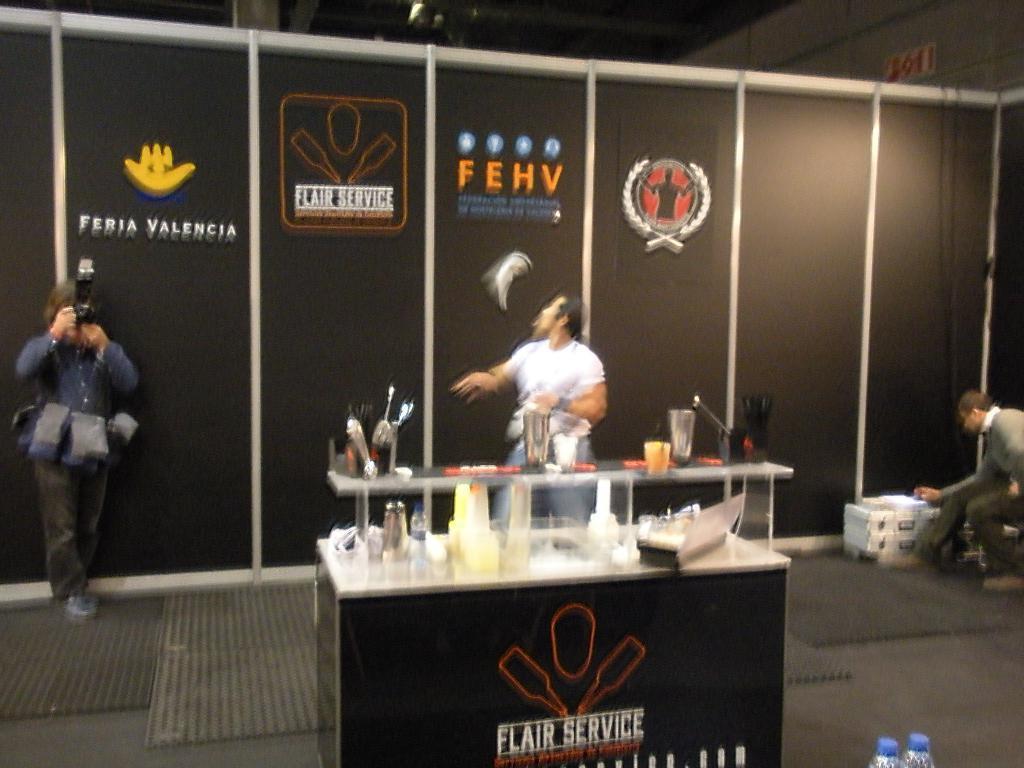Could you give a brief overview of what you see in this image? In this picture I can see three persons, there is a person holding a camera, there are some objects on the table and there are some objects on the glass shelf, which is on the table, there are mats, bottles, and in the background those are looking like boards. 